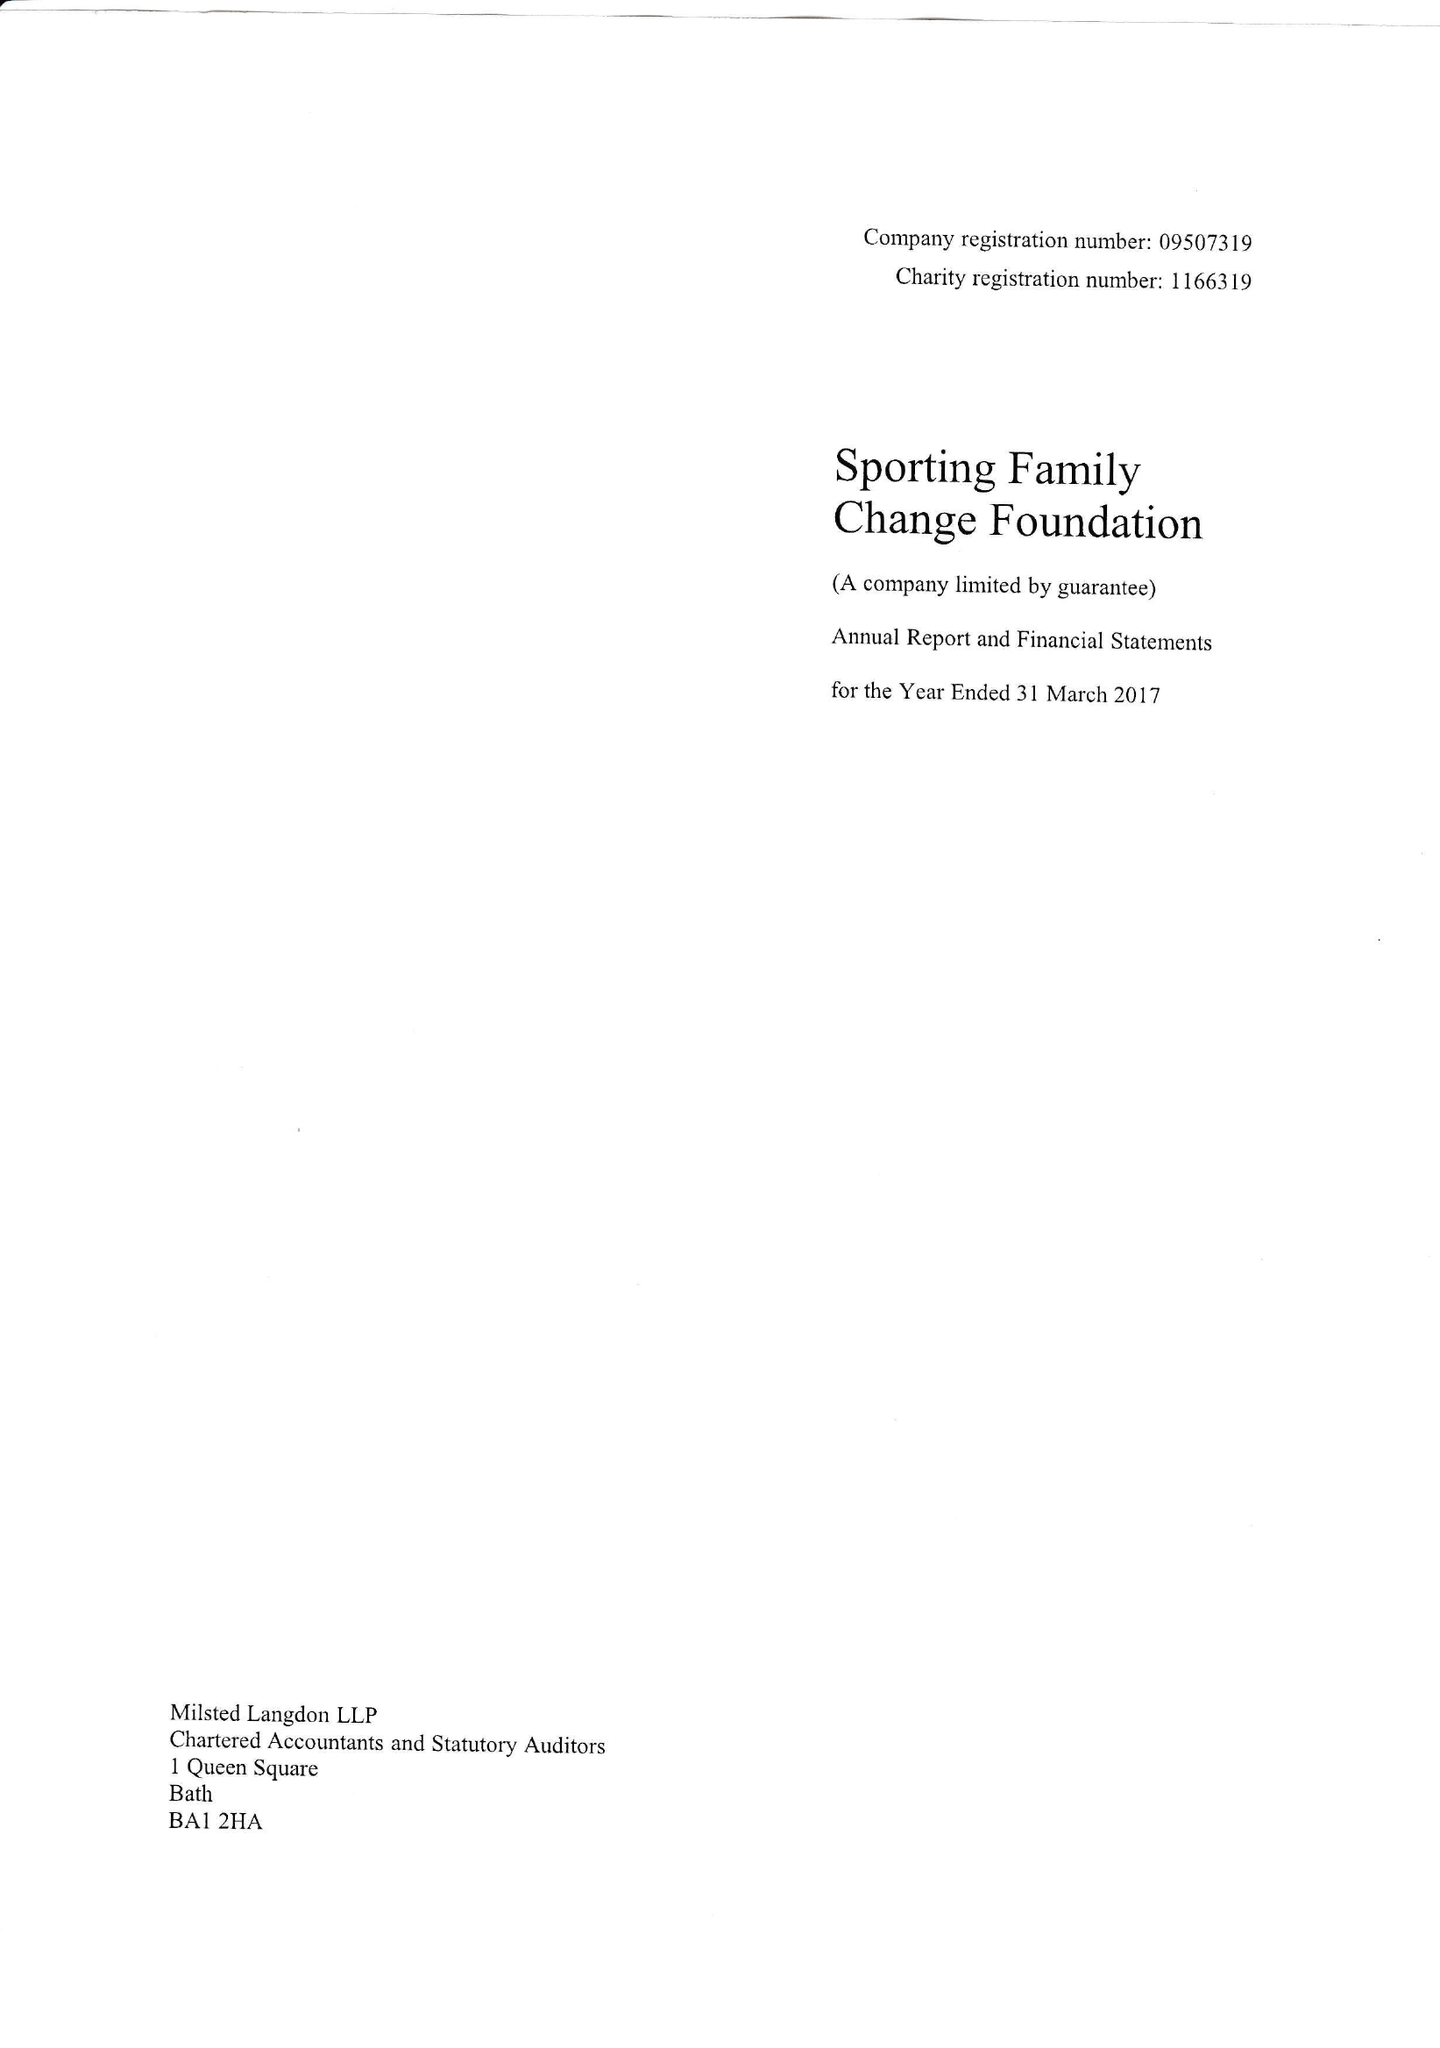What is the value for the income_annually_in_british_pounds?
Answer the question using a single word or phrase. 278920.00 